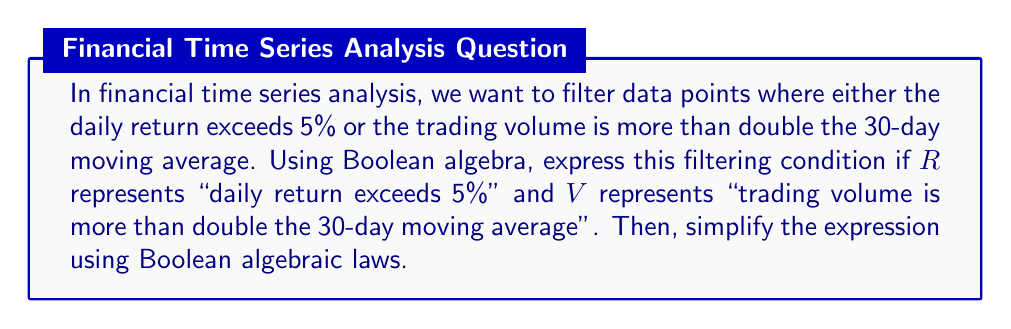Teach me how to tackle this problem. Let's approach this step-by-step:

1) First, we need to express the filtering condition in Boolean terms:
   We want data points where either $R$ is true OR $V$ is true.
   This is represented as: $R + V$

2) Now, let's consider the complement of this condition (i.e., the data points we want to exclude):
   $\overline{R + V}$

3) Using De Morgan's law, we can simplify this complement:
   $\overline{R + V} = \overline{R} \cdot \overline{V}$

4) This means we're excluding data points where both the daily return doesn't exceed 5% AND the trading volume isn't more than double the 30-day moving average.

5) To get back to our original filter condition, we need to take the complement of this result:
   $\overline{\overline{R} \cdot \overline{V}}$

6) Applying De Morgan's law again:
   $\overline{\overline{R} \cdot \overline{V}} = R + V$

7) This brings us back to our original expression, confirming that $R + V$ is indeed the simplest form of our filtering condition in Boolean algebra.

Therefore, the Boolean expression $R + V$ represents our data filtering technique and cannot be further simplified.
Answer: $R + V$ 